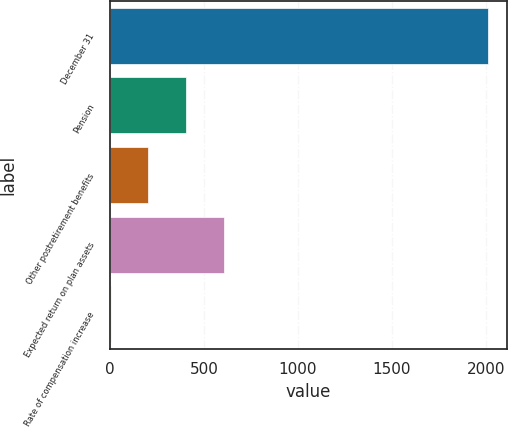Convert chart to OTSL. <chart><loc_0><loc_0><loc_500><loc_500><bar_chart><fcel>December 31<fcel>Pension<fcel>Other postretirement benefits<fcel>Expected return on plan assets<fcel>Rate of compensation increase<nl><fcel>2013<fcel>405.8<fcel>204.9<fcel>606.7<fcel>4<nl></chart> 